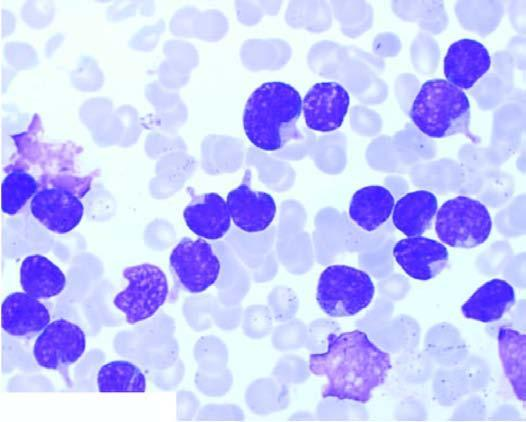re iseases large, with round to convoluted nuclei having high n/c ratio and no cytoplasmic granularity?
Answer the question using a single word or phrase. No 